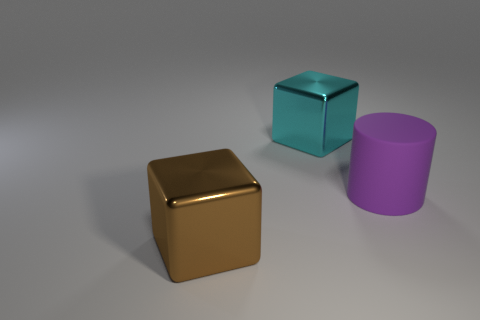Add 2 large brown cylinders. How many objects exist? 5 Subtract all blocks. How many objects are left? 1 Add 1 brown shiny cubes. How many brown shiny cubes are left? 2 Add 2 purple matte balls. How many purple matte balls exist? 2 Subtract 0 blue cylinders. How many objects are left? 3 Subtract all large brown shiny cubes. Subtract all matte cylinders. How many objects are left? 1 